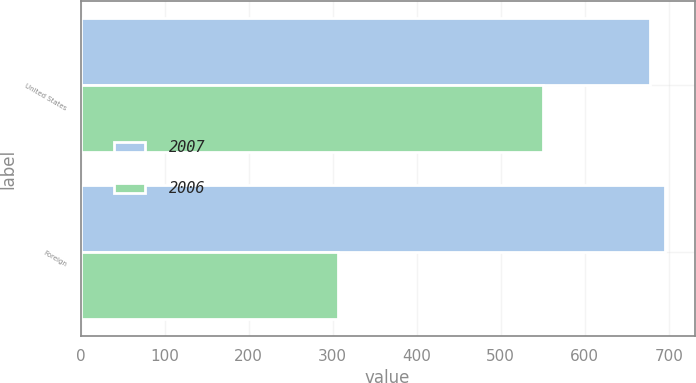<chart> <loc_0><loc_0><loc_500><loc_500><stacked_bar_chart><ecel><fcel>United States<fcel>Foreign<nl><fcel>2007<fcel>678<fcel>696<nl><fcel>2006<fcel>550<fcel>307<nl></chart> 